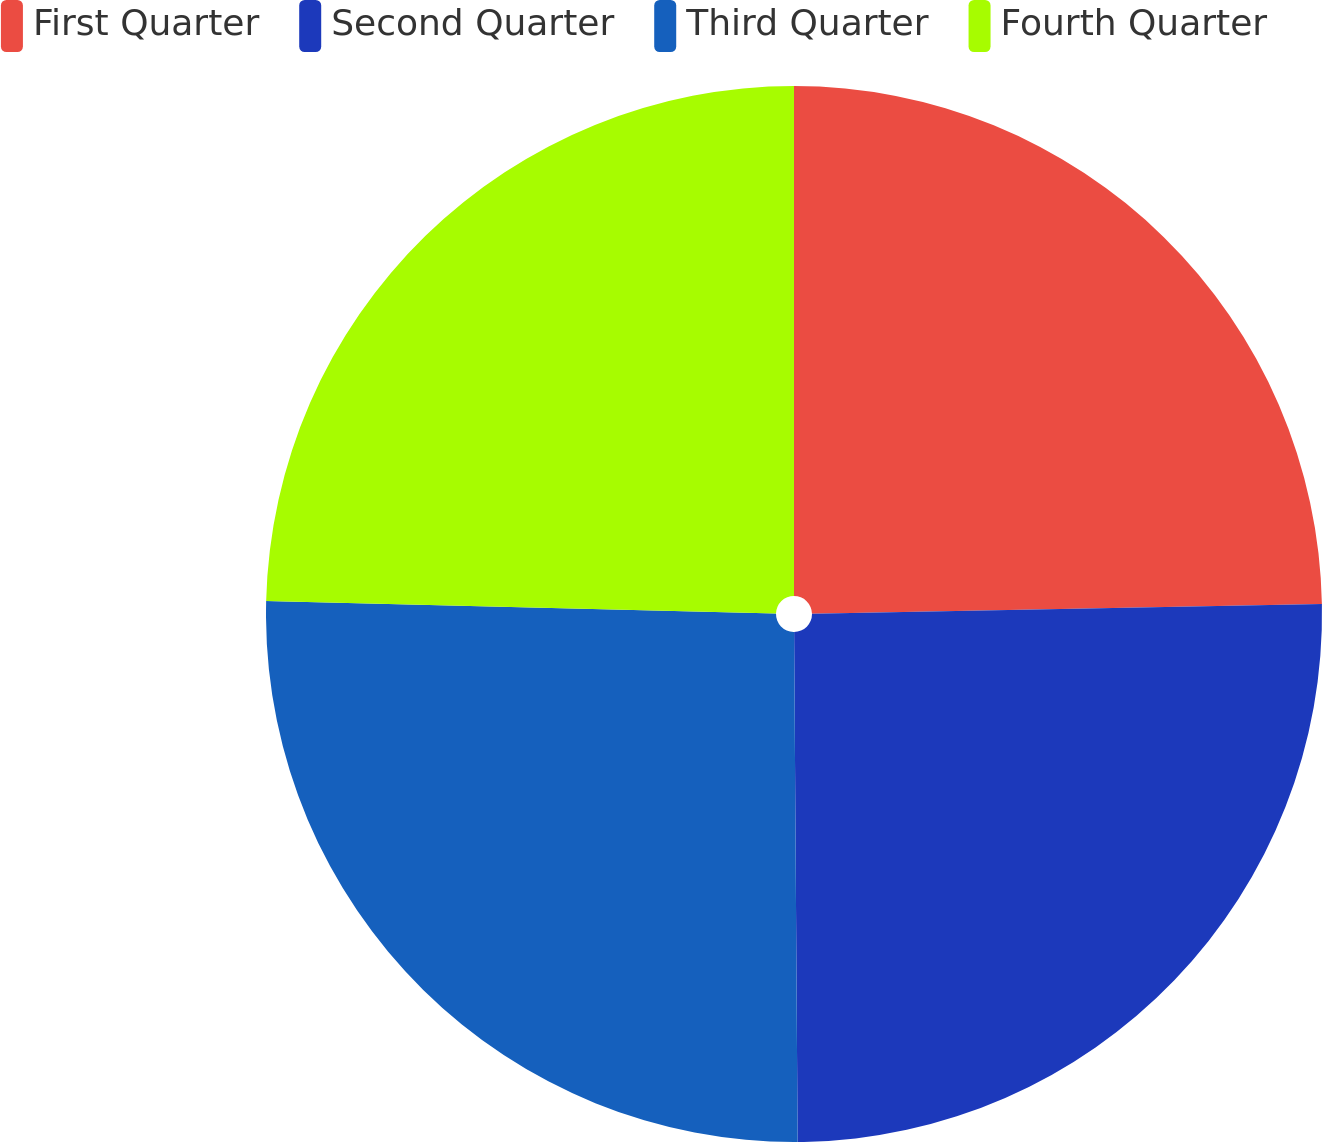Convert chart. <chart><loc_0><loc_0><loc_500><loc_500><pie_chart><fcel>First Quarter<fcel>Second Quarter<fcel>Third Quarter<fcel>Fourth Quarter<nl><fcel>24.7%<fcel>25.19%<fcel>25.5%<fcel>24.61%<nl></chart> 